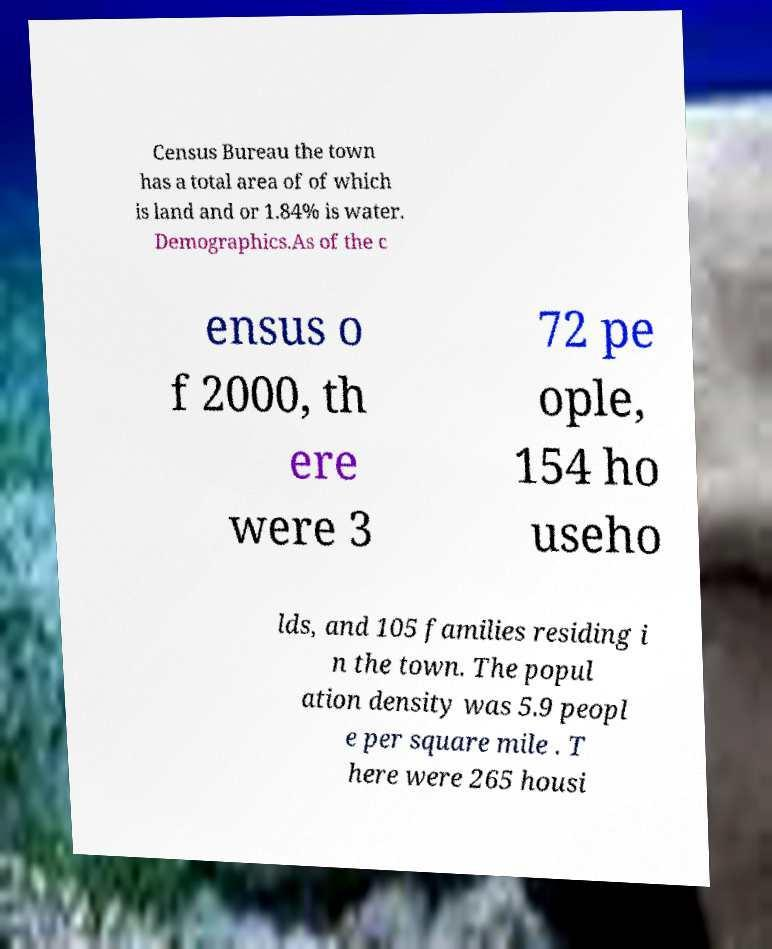Could you assist in decoding the text presented in this image and type it out clearly? Census Bureau the town has a total area of of which is land and or 1.84% is water. Demographics.As of the c ensus o f 2000, th ere were 3 72 pe ople, 154 ho useho lds, and 105 families residing i n the town. The popul ation density was 5.9 peopl e per square mile . T here were 265 housi 